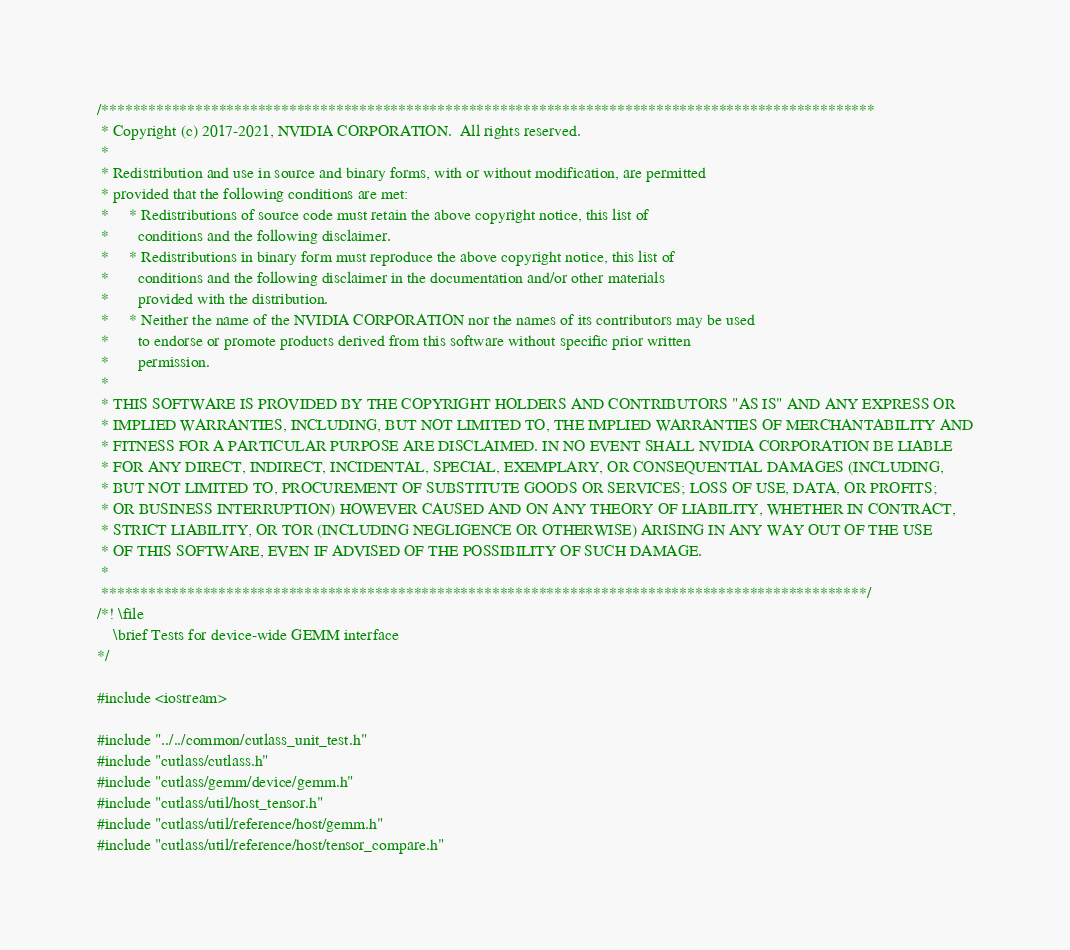Convert code to text. <code><loc_0><loc_0><loc_500><loc_500><_Cuda_>/***************************************************************************************************
 * Copyright (c) 2017-2021, NVIDIA CORPORATION.  All rights reserved.
 *
 * Redistribution and use in source and binary forms, with or without modification, are permitted
 * provided that the following conditions are met:
 *     * Redistributions of source code must retain the above copyright notice, this list of
 *       conditions and the following disclaimer.
 *     * Redistributions in binary form must reproduce the above copyright notice, this list of
 *       conditions and the following disclaimer in the documentation and/or other materials
 *       provided with the distribution.
 *     * Neither the name of the NVIDIA CORPORATION nor the names of its contributors may be used
 *       to endorse or promote products derived from this software without specific prior written
 *       permission.
 *
 * THIS SOFTWARE IS PROVIDED BY THE COPYRIGHT HOLDERS AND CONTRIBUTORS "AS IS" AND ANY EXPRESS OR
 * IMPLIED WARRANTIES, INCLUDING, BUT NOT LIMITED TO, THE IMPLIED WARRANTIES OF MERCHANTABILITY AND
 * FITNESS FOR A PARTICULAR PURPOSE ARE DISCLAIMED. IN NO EVENT SHALL NVIDIA CORPORATION BE LIABLE
 * FOR ANY DIRECT, INDIRECT, INCIDENTAL, SPECIAL, EXEMPLARY, OR CONSEQUENTIAL DAMAGES (INCLUDING,
 * BUT NOT LIMITED TO, PROCUREMENT OF SUBSTITUTE GOODS OR SERVICES; LOSS OF USE, DATA, OR PROFITS;
 * OR BUSINESS INTERRUPTION) HOWEVER CAUSED AND ON ANY THEORY OF LIABILITY, WHETHER IN CONTRACT,
 * STRICT LIABILITY, OR TOR (INCLUDING NEGLIGENCE OR OTHERWISE) ARISING IN ANY WAY OUT OF THE USE
 * OF THIS SOFTWARE, EVEN IF ADVISED OF THE POSSIBILITY OF SUCH DAMAGE.
 *
 **************************************************************************************************/
/*! \file
    \brief Tests for device-wide GEMM interface
*/

#include <iostream>

#include "../../common/cutlass_unit_test.h"
#include "cutlass/cutlass.h"
#include "cutlass/gemm/device/gemm.h"
#include "cutlass/util/host_tensor.h"
#include "cutlass/util/reference/host/gemm.h"
#include "cutlass/util/reference/host/tensor_compare.h"</code> 